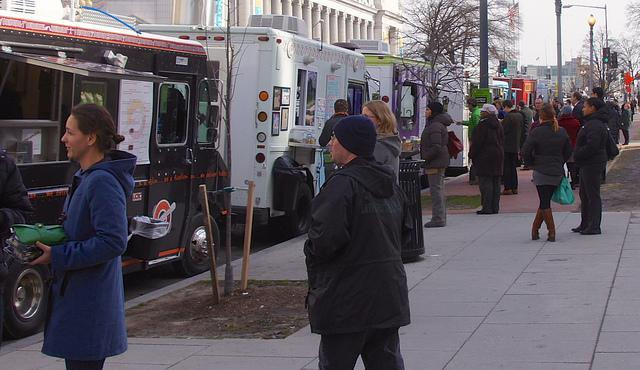What is the color of second vehicle? Please explain your reasoning. white. The first food truck is black, whereas the second one is white. both (as well as the third truck) have customers waiting to order. 